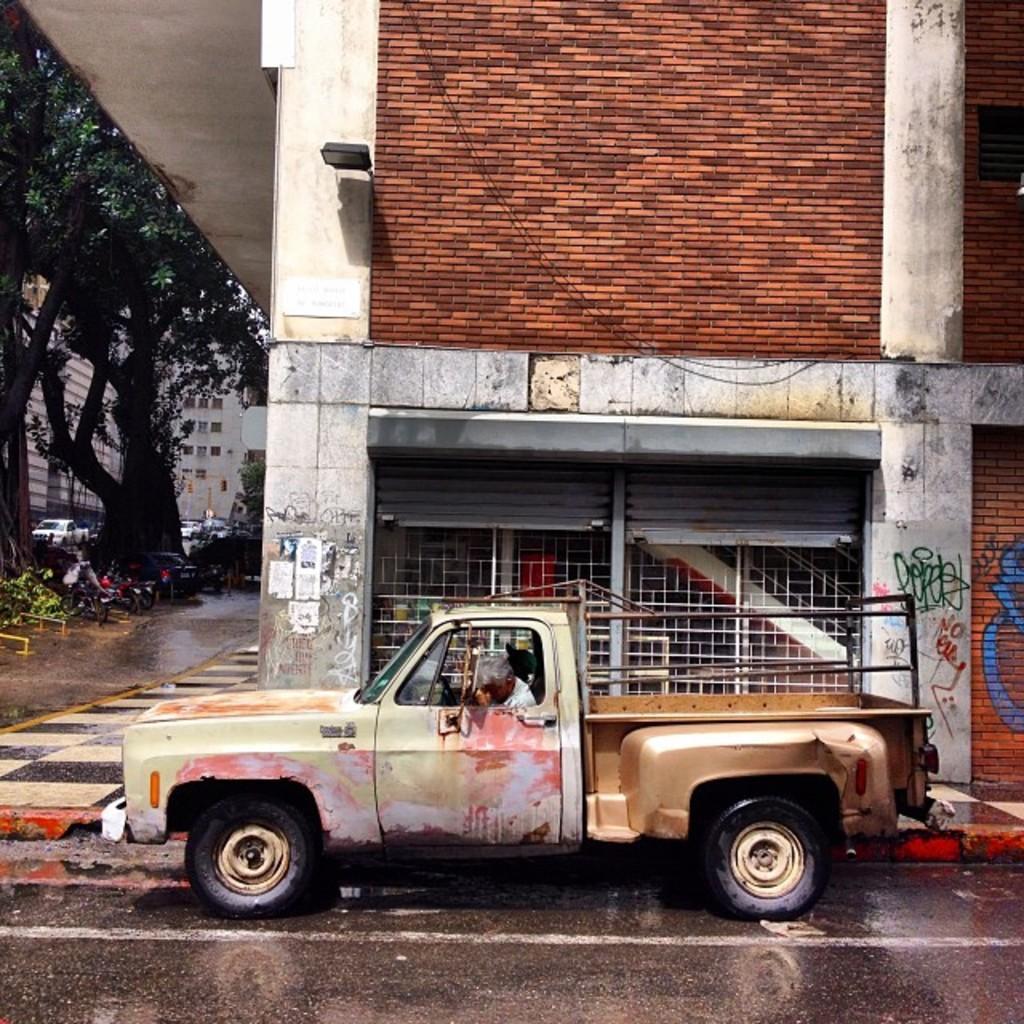Can you describe this image briefly? In this picture I can observe a vehicle on the road. There is a person sitting in the vehicle. On the left side I can observe some trees. In the background there are buildings. 